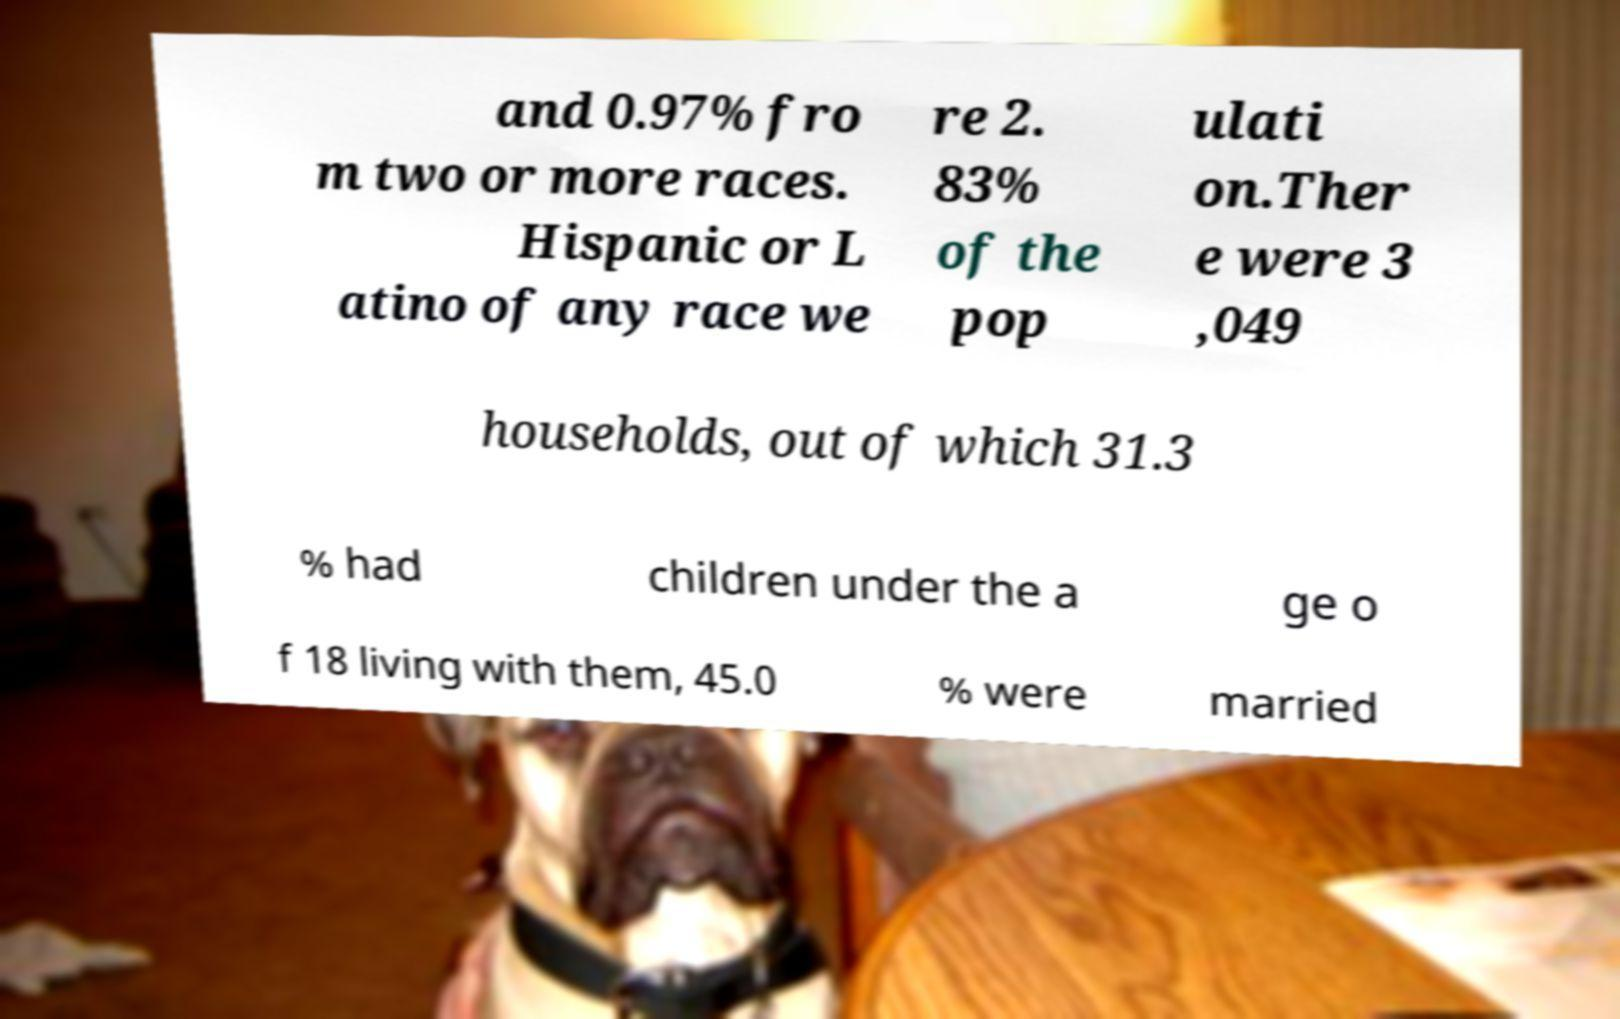Please identify and transcribe the text found in this image. and 0.97% fro m two or more races. Hispanic or L atino of any race we re 2. 83% of the pop ulati on.Ther e were 3 ,049 households, out of which 31.3 % had children under the a ge o f 18 living with them, 45.0 % were married 